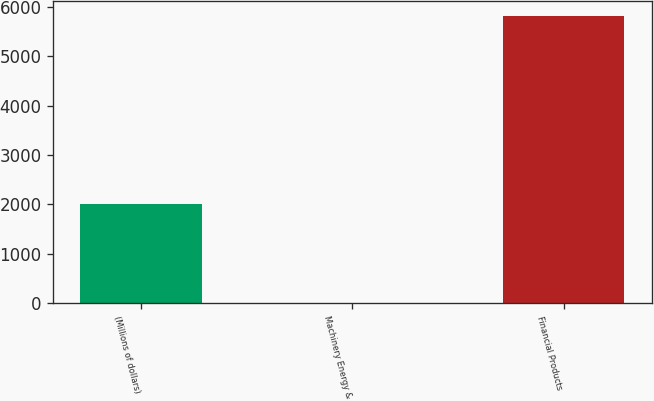Convert chart to OTSL. <chart><loc_0><loc_0><loc_500><loc_500><bar_chart><fcel>(Millions of dollars)<fcel>Machinery Energy &<fcel>Financial Products<nl><fcel>2019<fcel>10<fcel>5820<nl></chart> 